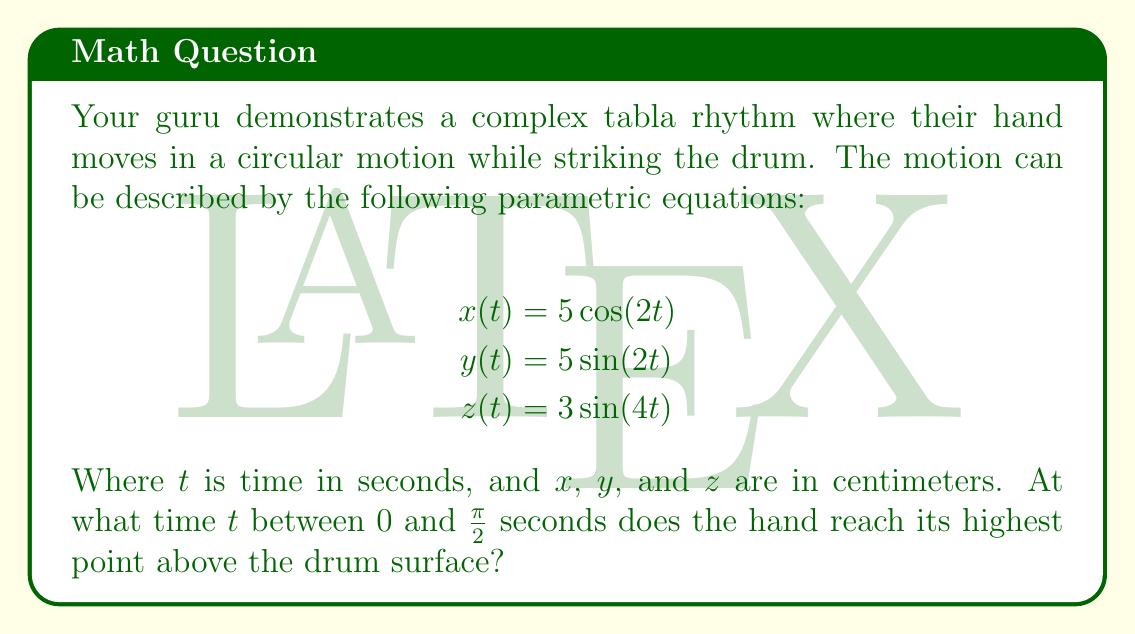Give your solution to this math problem. To find the highest point of the hand's motion, we need to focus on the $z$-coordinate, which represents the vertical displacement from the drum surface.

1) The $z$-coordinate is given by $z(t) = 3\sin(4t)$.

2) To find the maximum value of $z(t)$, we need to find where its derivative equals zero:

   $$\frac{dz}{dt} = 12\cos(4t)$$

3) Set this equal to zero:

   $$12\cos(4t) = 0$$

4) Solve for $t$:

   $$\cos(4t) = 0$$
   $$4t = \frac{\pi}{2} + \pi n$$ (where $n$ is an integer)
   $$t = \frac{\pi}{8} + \frac{\pi n}{4}$$

5) The question asks for $t$ between 0 and $\frac{\pi}{2}$, so we choose $n = 0$:

   $$t = \frac{\pi}{8} \approx 0.3927 \text{ seconds}$$

6) To confirm this is a maximum (not a minimum), we can check the second derivative:

   $$\frac{d^2z}{dt^2} = -48\sin(4t)$$

   At $t = \frac{\pi}{8}$, this is negative, confirming a maximum.

Therefore, the hand reaches its highest point at $t = \frac{\pi}{8}$ seconds.
Answer: $t = \frac{\pi}{8}$ seconds 